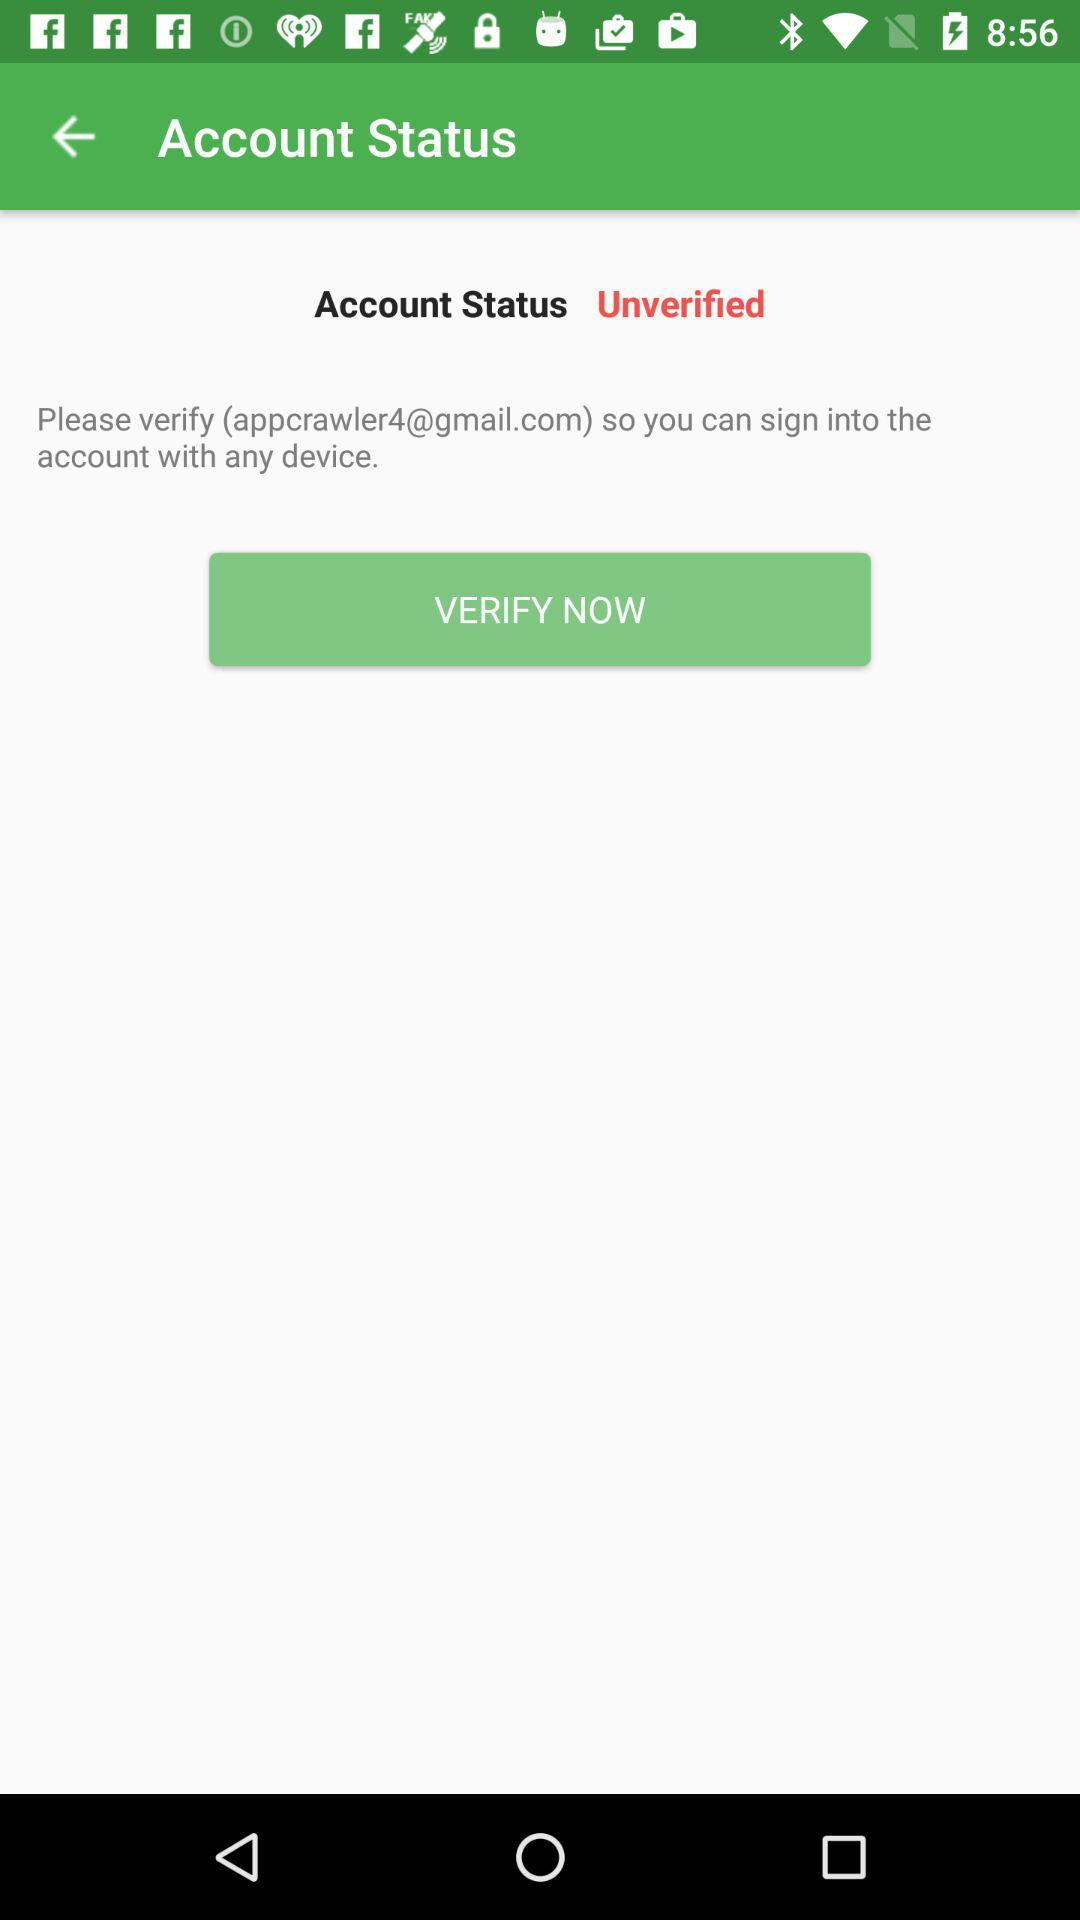What is the account status? The account status is unverified. 